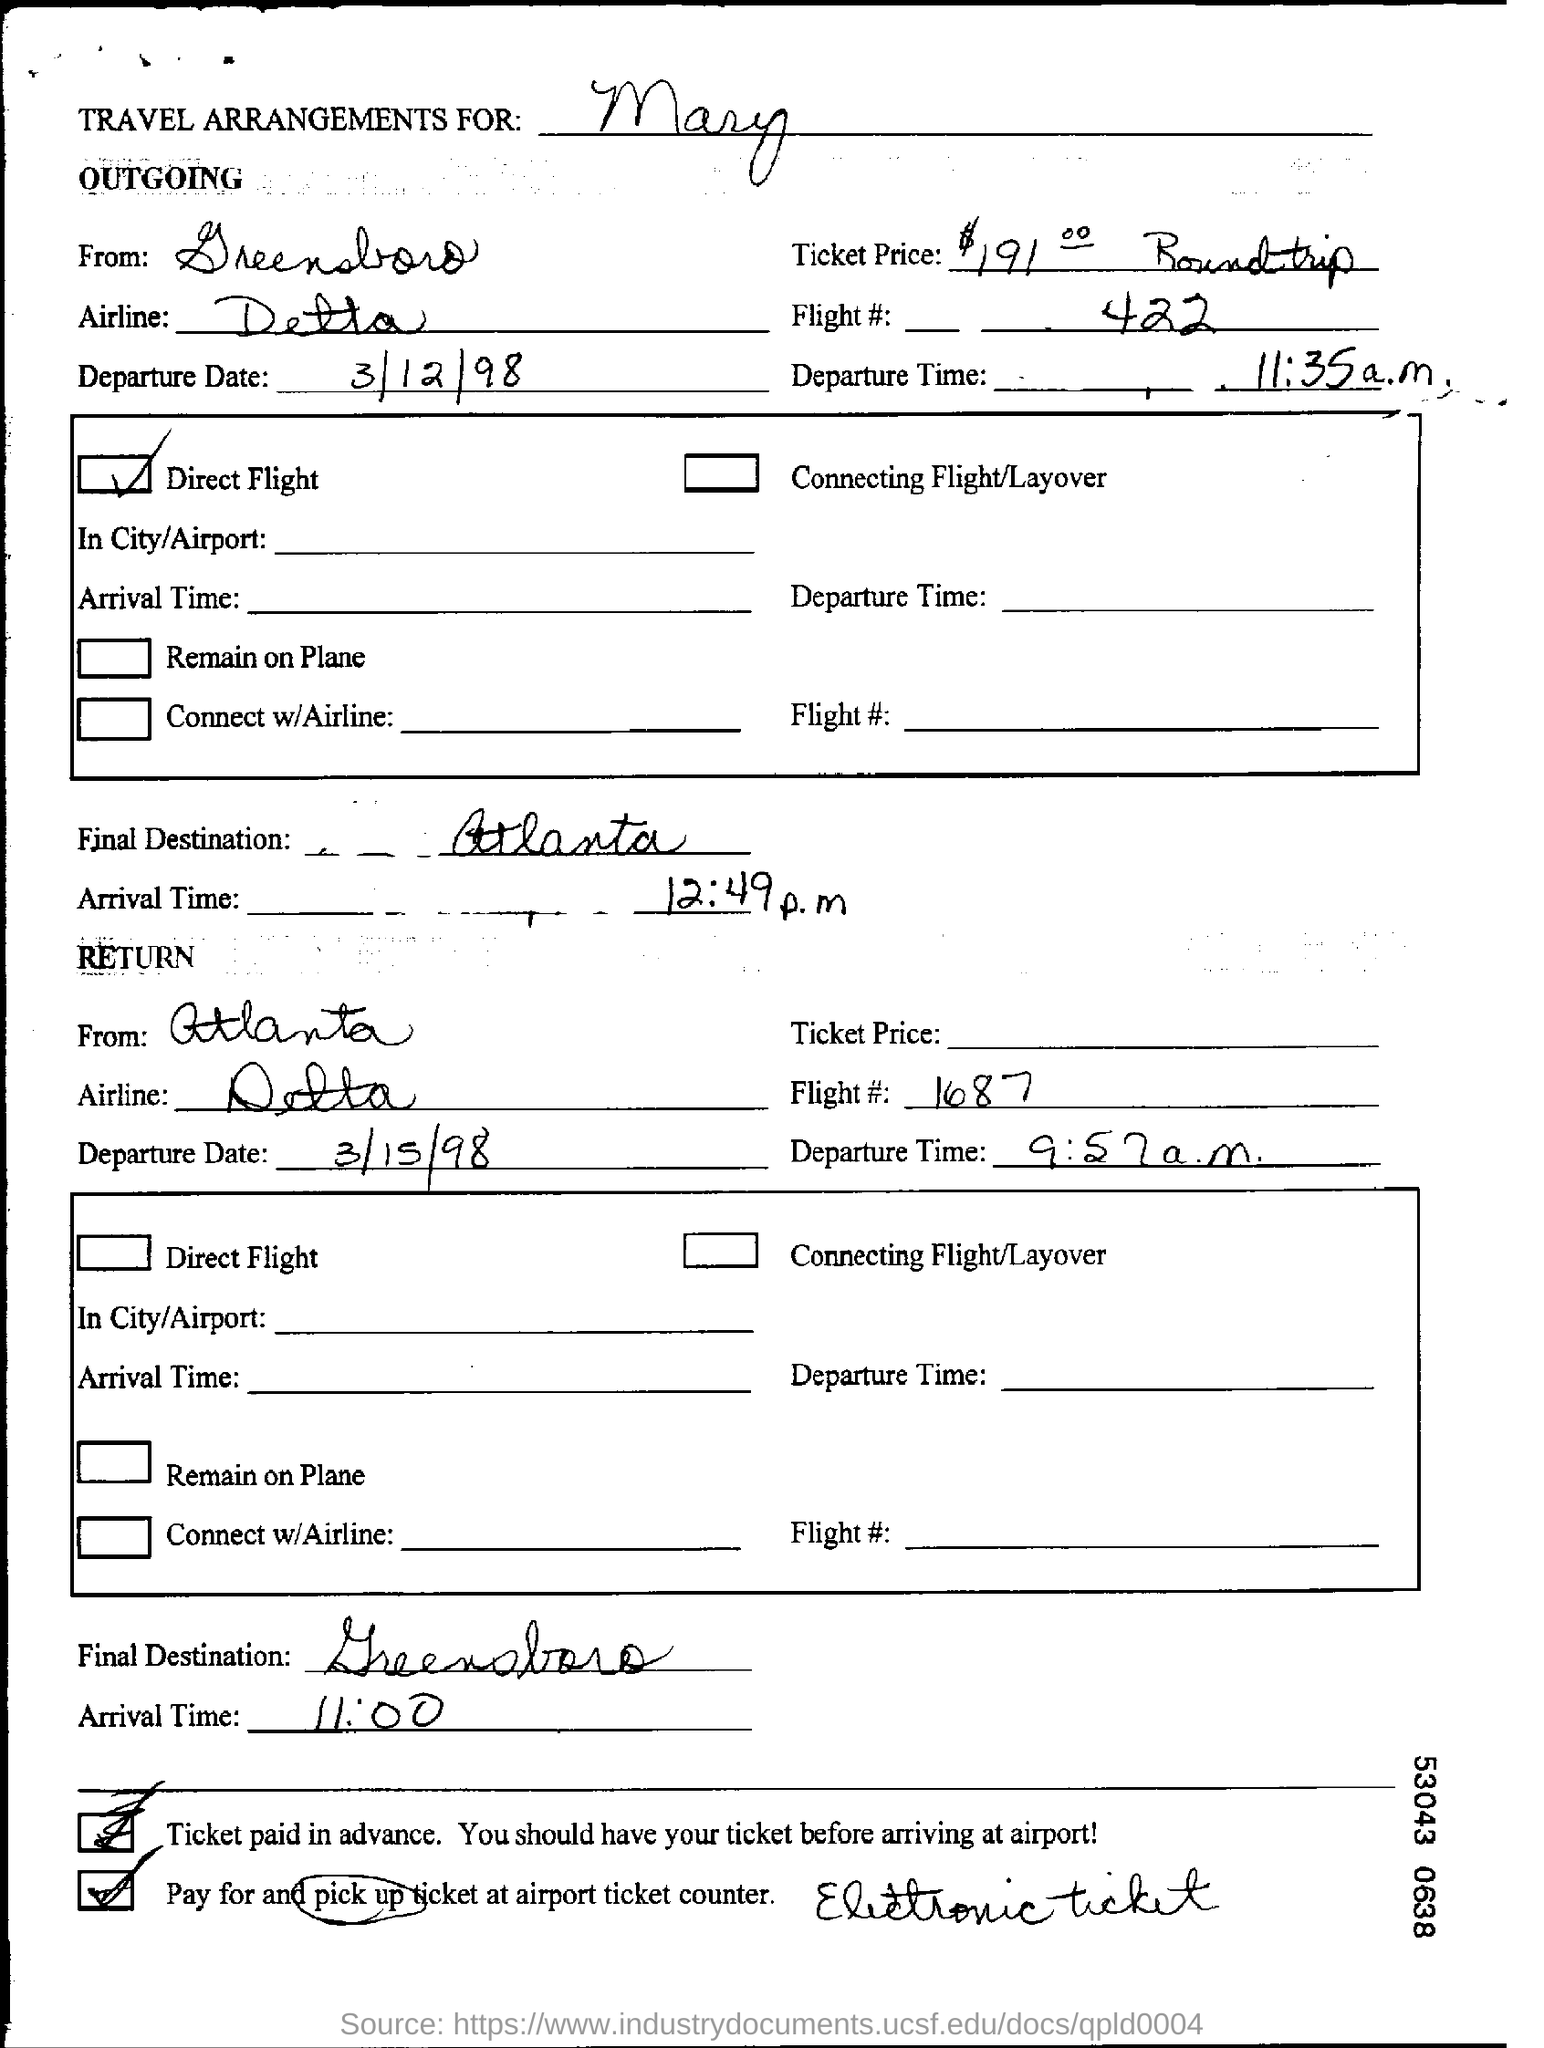For whom is the travel arrangements made ?
Offer a terse response. Mary. What is the Departure Date of the outgoing journey?
Offer a very short reply. 3/12/98. What is the final destination of the outgoing journey?
Make the answer very short. Atlanta. What is the flight number in the return journey ?
Make the answer very short. 1687. What is the departure time of the return journey ?
Your answer should be compact. 9:57 a.m. What is the arrival time of the return flight?
Give a very brief answer. 11:00. What is the origin of the outgoing journey?
Provide a succinct answer. Greensboro. Which one is a direct flight - Outgoing or Return ?
Offer a very short reply. Outgoing. 